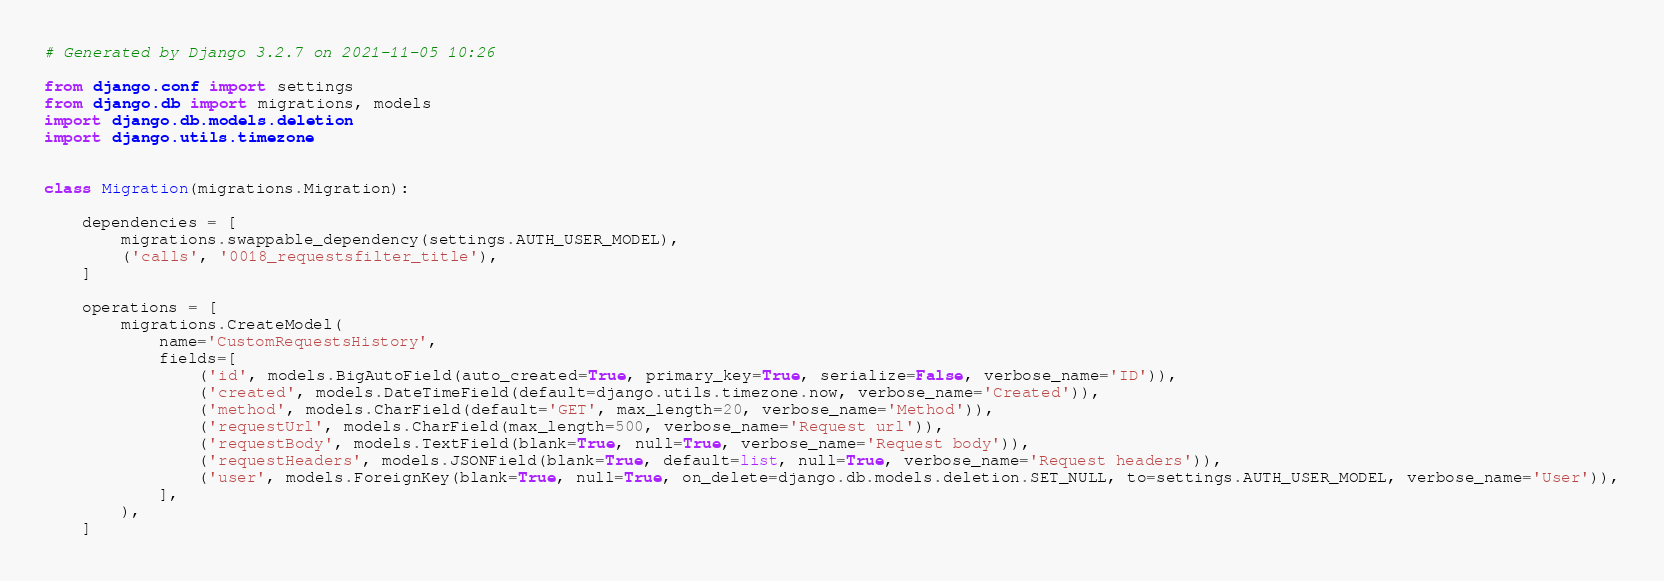Convert code to text. <code><loc_0><loc_0><loc_500><loc_500><_Python_># Generated by Django 3.2.7 on 2021-11-05 10:26

from django.conf import settings
from django.db import migrations, models
import django.db.models.deletion
import django.utils.timezone


class Migration(migrations.Migration):

    dependencies = [
        migrations.swappable_dependency(settings.AUTH_USER_MODEL),
        ('calls', '0018_requestsfilter_title'),
    ]

    operations = [
        migrations.CreateModel(
            name='CustomRequestsHistory',
            fields=[
                ('id', models.BigAutoField(auto_created=True, primary_key=True, serialize=False, verbose_name='ID')),
                ('created', models.DateTimeField(default=django.utils.timezone.now, verbose_name='Created')),
                ('method', models.CharField(default='GET', max_length=20, verbose_name='Method')),
                ('requestUrl', models.CharField(max_length=500, verbose_name='Request url')),
                ('requestBody', models.TextField(blank=True, null=True, verbose_name='Request body')),
                ('requestHeaders', models.JSONField(blank=True, default=list, null=True, verbose_name='Request headers')),
                ('user', models.ForeignKey(blank=True, null=True, on_delete=django.db.models.deletion.SET_NULL, to=settings.AUTH_USER_MODEL, verbose_name='User')),
            ],
        ),
    ]
</code> 